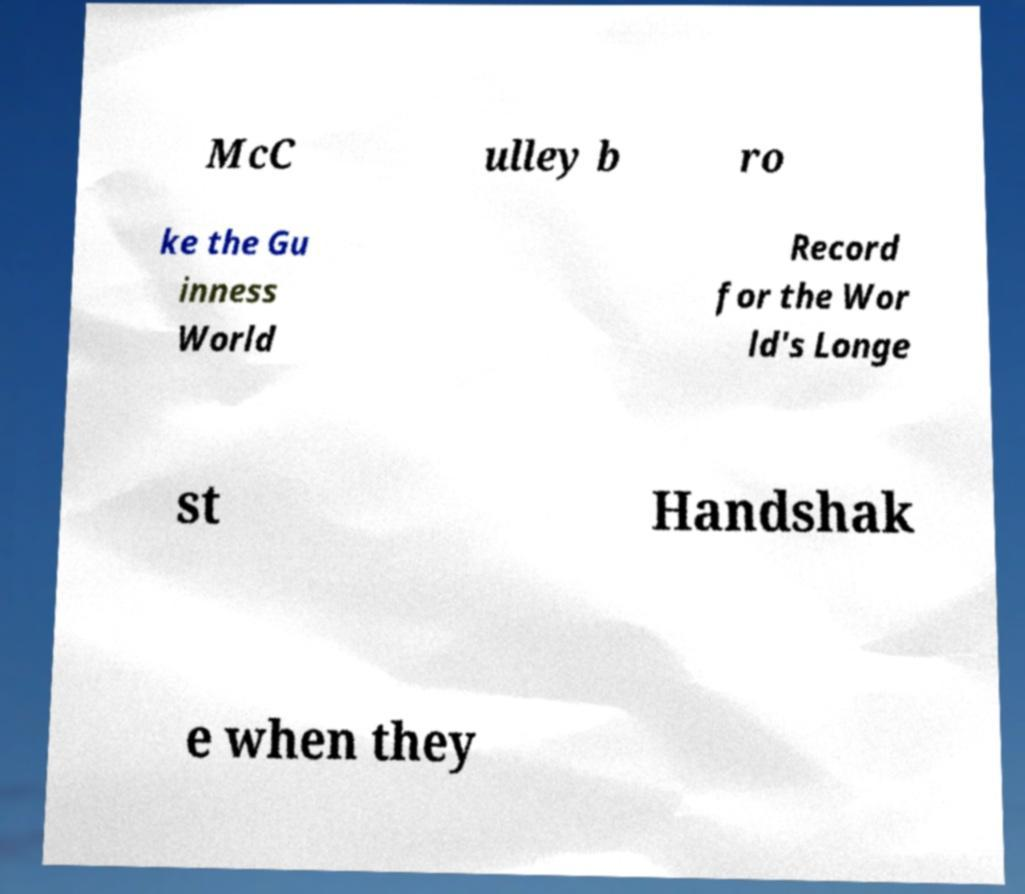Can you accurately transcribe the text from the provided image for me? McC ulley b ro ke the Gu inness World Record for the Wor ld's Longe st Handshak e when they 